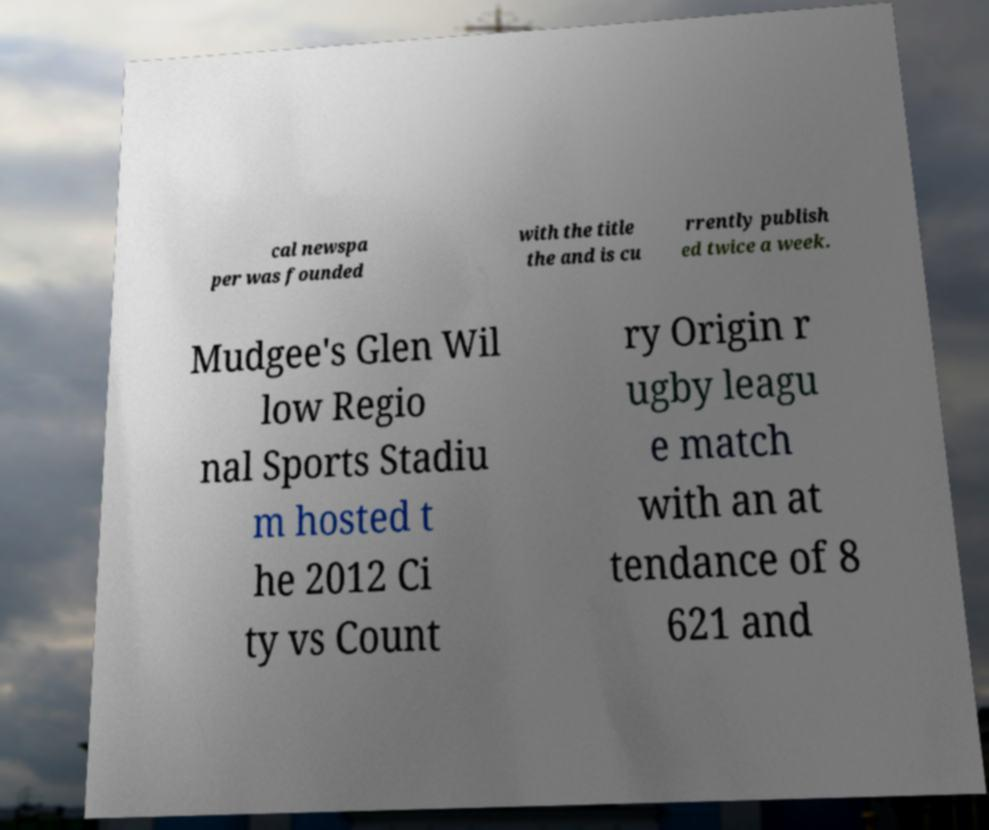Could you extract and type out the text from this image? cal newspa per was founded with the title the and is cu rrently publish ed twice a week. Mudgee's Glen Wil low Regio nal Sports Stadiu m hosted t he 2012 Ci ty vs Count ry Origin r ugby leagu e match with an at tendance of 8 621 and 